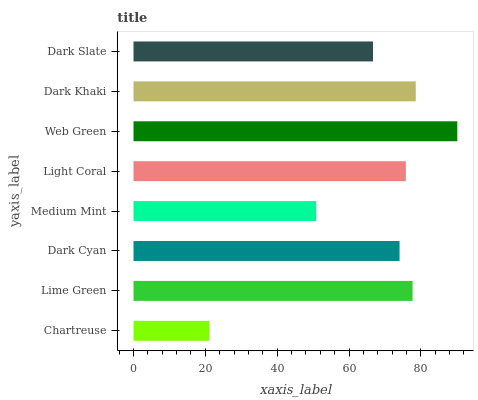Is Chartreuse the minimum?
Answer yes or no. Yes. Is Web Green the maximum?
Answer yes or no. Yes. Is Lime Green the minimum?
Answer yes or no. No. Is Lime Green the maximum?
Answer yes or no. No. Is Lime Green greater than Chartreuse?
Answer yes or no. Yes. Is Chartreuse less than Lime Green?
Answer yes or no. Yes. Is Chartreuse greater than Lime Green?
Answer yes or no. No. Is Lime Green less than Chartreuse?
Answer yes or no. No. Is Light Coral the high median?
Answer yes or no. Yes. Is Dark Cyan the low median?
Answer yes or no. Yes. Is Dark Cyan the high median?
Answer yes or no. No. Is Light Coral the low median?
Answer yes or no. No. 